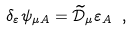Convert formula to latex. <formula><loc_0><loc_0><loc_500><loc_500>\delta _ { \varepsilon } \psi _ { \mu A } = \widetilde { \mathcal { D } } _ { \mu } \varepsilon _ { A } \ ,</formula> 